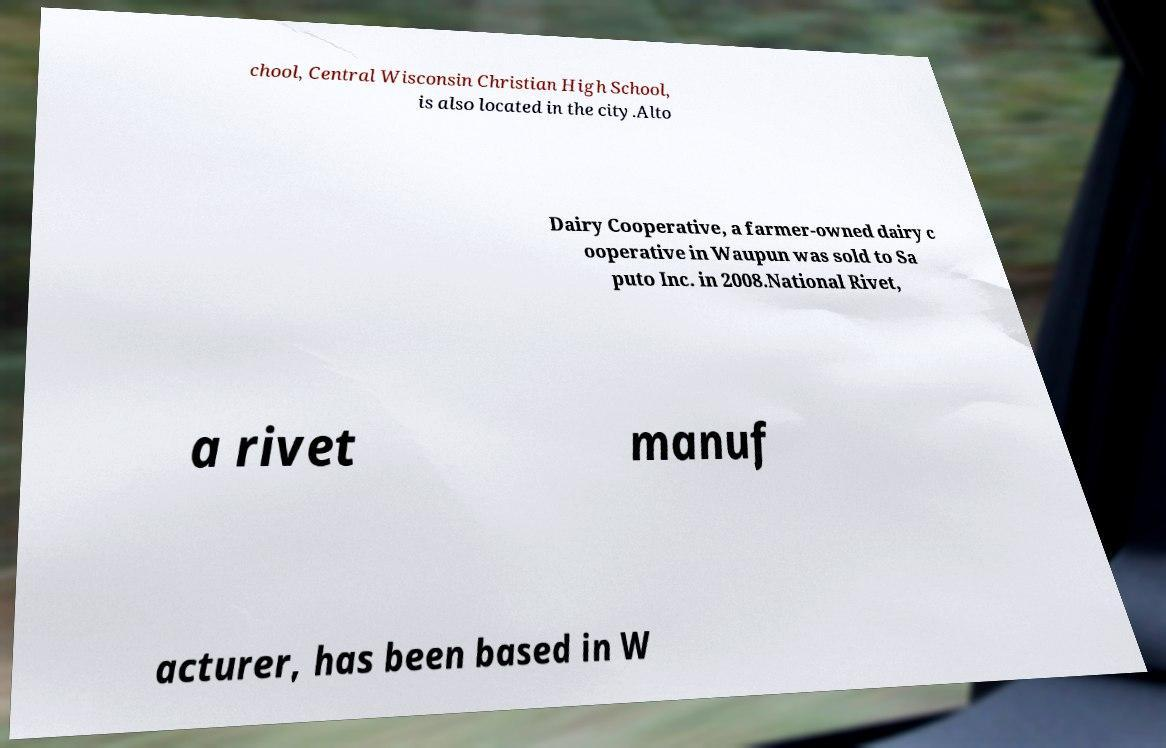Can you read and provide the text displayed in the image?This photo seems to have some interesting text. Can you extract and type it out for me? chool, Central Wisconsin Christian High School, is also located in the city.Alto Dairy Cooperative, a farmer-owned dairy c ooperative in Waupun was sold to Sa puto Inc. in 2008.National Rivet, a rivet manuf acturer, has been based in W 